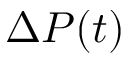<formula> <loc_0><loc_0><loc_500><loc_500>\Delta P ( t )</formula> 